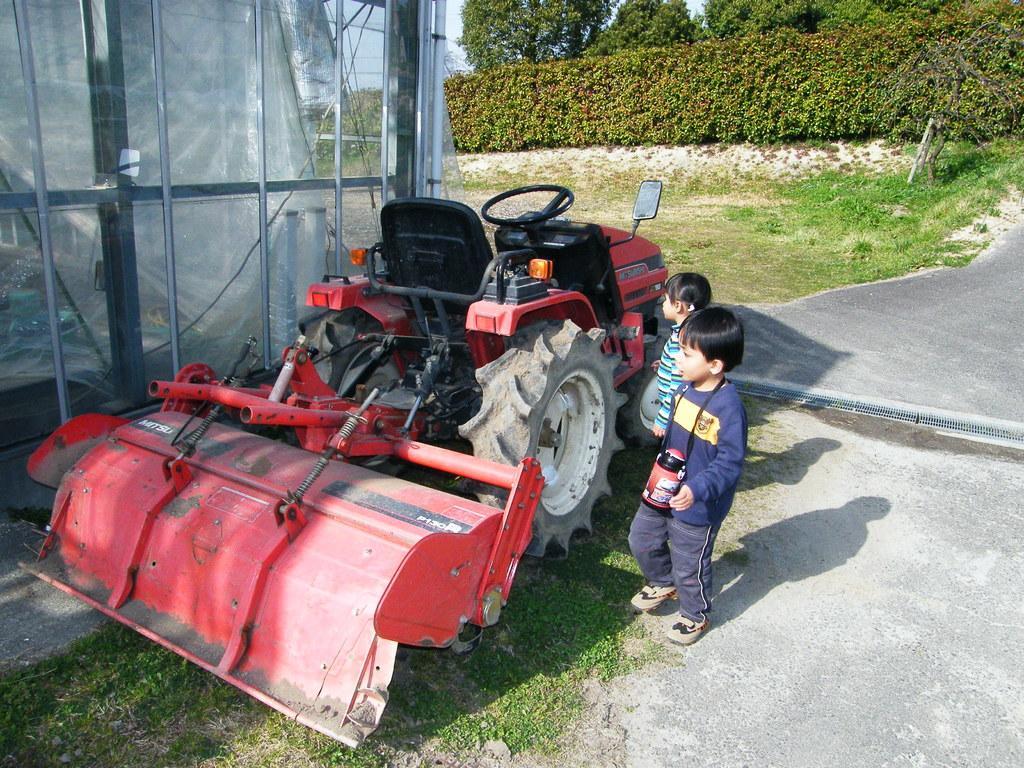Describe this image in one or two sentences. In this image we can see a vehicle. There are two persons in the image. There is a grassy land in the image. There are many trees and plants in the image. There is a road and a shed in the image. 